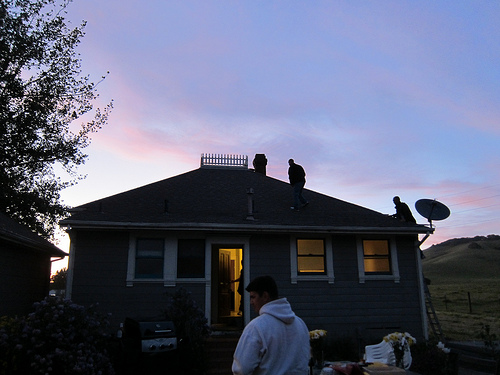<image>
Can you confirm if the sky is behind the building? Yes. From this viewpoint, the sky is positioned behind the building, with the building partially or fully occluding the sky. Is there a man to the right of the tree? Yes. From this viewpoint, the man is positioned to the right side relative to the tree. Is the man in the house? No. The man is not contained within the house. These objects have a different spatial relationship. 